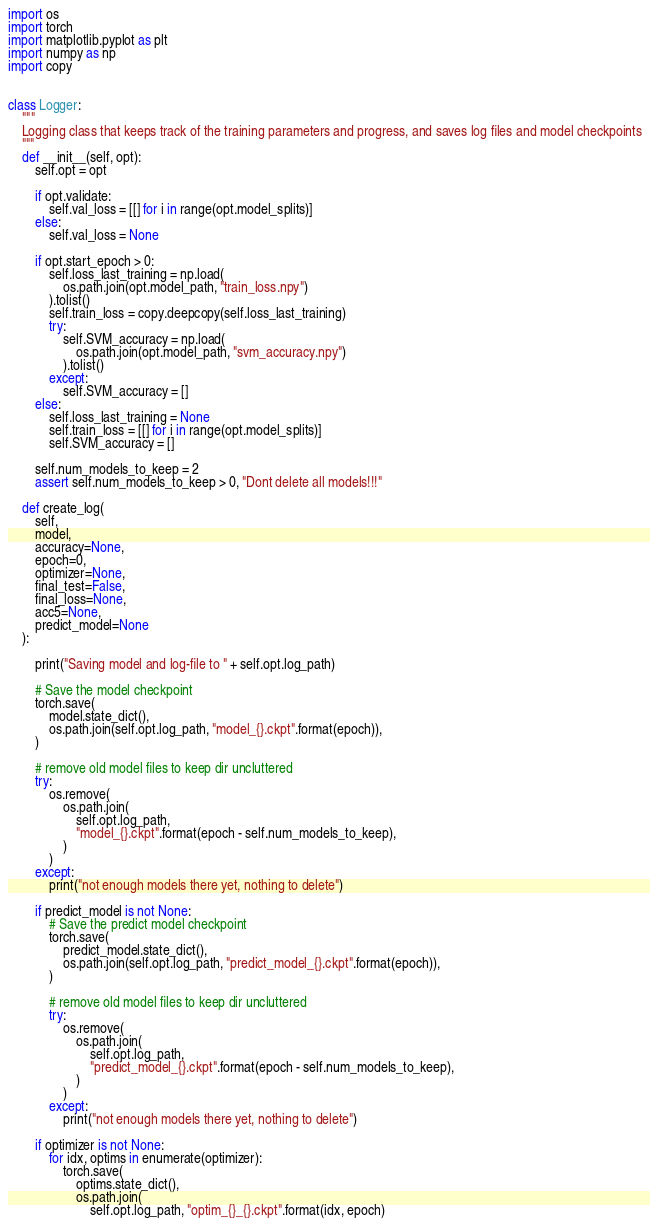Convert code to text. <code><loc_0><loc_0><loc_500><loc_500><_Python_>import os
import torch
import matplotlib.pyplot as plt
import numpy as np
import copy


class Logger:
    """
    Logging class that keeps track of the training parameters and progress, and saves log files and model checkpoints
    """
    def __init__(self, opt):
        self.opt = opt

        if opt.validate:
            self.val_loss = [[] for i in range(opt.model_splits)]
        else:
            self.val_loss = None

        if opt.start_epoch > 0:
            self.loss_last_training = np.load(
                os.path.join(opt.model_path, "train_loss.npy")
            ).tolist()
            self.train_loss = copy.deepcopy(self.loss_last_training)
            try:
                self.SVM_accuracy = np.load(
                    os.path.join(opt.model_path, "svm_accuracy.npy")
                ).tolist()
            except:
                self.SVM_accuracy = []
        else:
            self.loss_last_training = None
            self.train_loss = [[] for i in range(opt.model_splits)]
            self.SVM_accuracy = []

        self.num_models_to_keep = 2
        assert self.num_models_to_keep > 0, "Dont delete all models!!!"

    def create_log(
        self,
        model,
        accuracy=None,
        epoch=0,
        optimizer=None,
        final_test=False,
        final_loss=None,
        acc5=None,
        predict_model=None
    ):

        print("Saving model and log-file to " + self.opt.log_path)

        # Save the model checkpoint
        torch.save(
            model.state_dict(),
            os.path.join(self.opt.log_path, "model_{}.ckpt".format(epoch)),
        )

        # remove old model files to keep dir uncluttered
        try:
            os.remove(
                os.path.join(
                    self.opt.log_path,
                    "model_{}.ckpt".format(epoch - self.num_models_to_keep),
                )
            )
        except:
            print("not enough models there yet, nothing to delete")

        if predict_model is not None:
            # Save the predict model checkpoint
            torch.save(
                predict_model.state_dict(),
                os.path.join(self.opt.log_path, "predict_model_{}.ckpt".format(epoch)),
            )

            # remove old model files to keep dir uncluttered
            try:
                os.remove(
                    os.path.join(
                        self.opt.log_path,
                        "predict_model_{}.ckpt".format(epoch - self.num_models_to_keep),
                    )
                )
            except:
                print("not enough models there yet, nothing to delete")

        if optimizer is not None:
            for idx, optims in enumerate(optimizer):
                torch.save(
                    optims.state_dict(),
                    os.path.join(
                        self.opt.log_path, "optim_{}_{}.ckpt".format(idx, epoch)</code> 